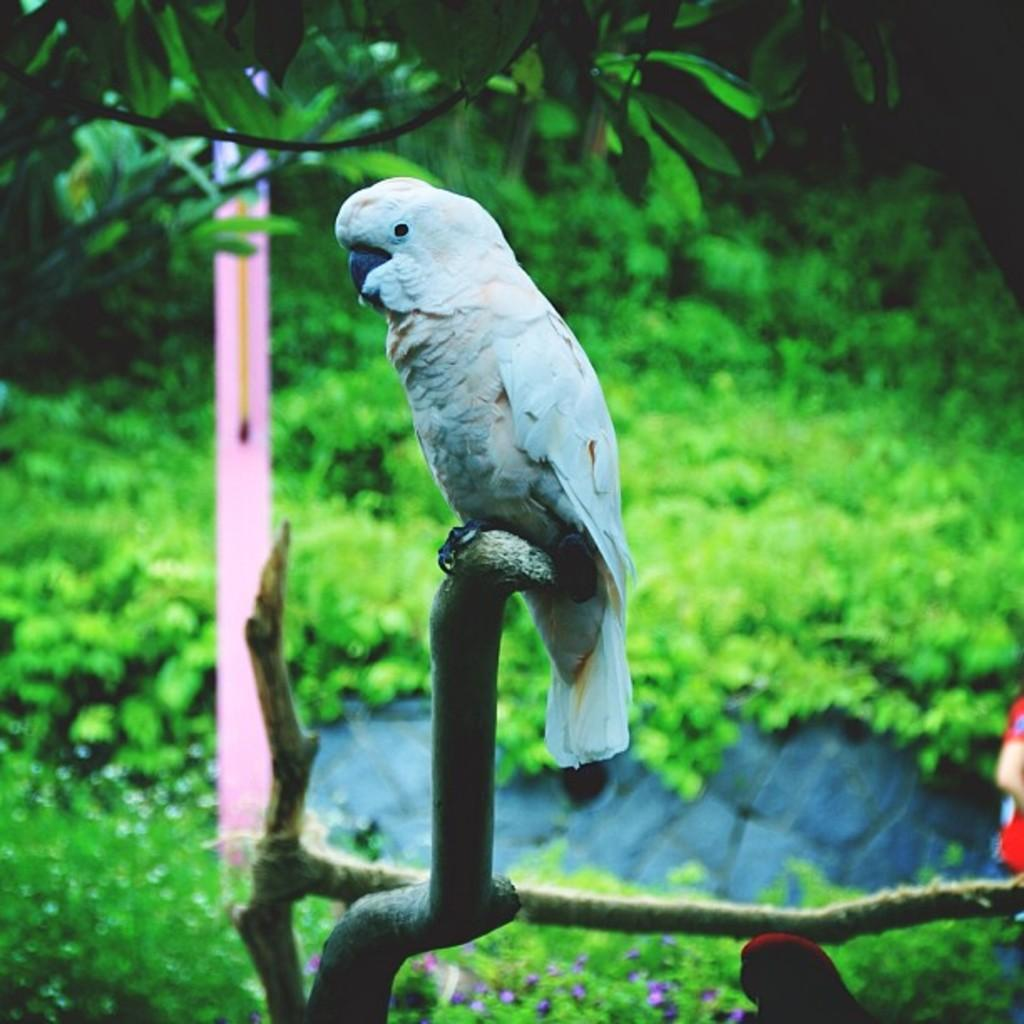Where was the image taken? The image was taken outside. What can be seen in the image besides the outdoor setting? There are plants and a parrot in the image. Can you describe the parrot's location in the image? The parrot is in the middle of the image. What type of screw can be seen holding the library books together in the image? There is no library or screw present in the image; it features plants and a parrot. Can you describe the squirrel's interaction with the parrot in the image? There is no squirrel present in the image, only a parrot. 